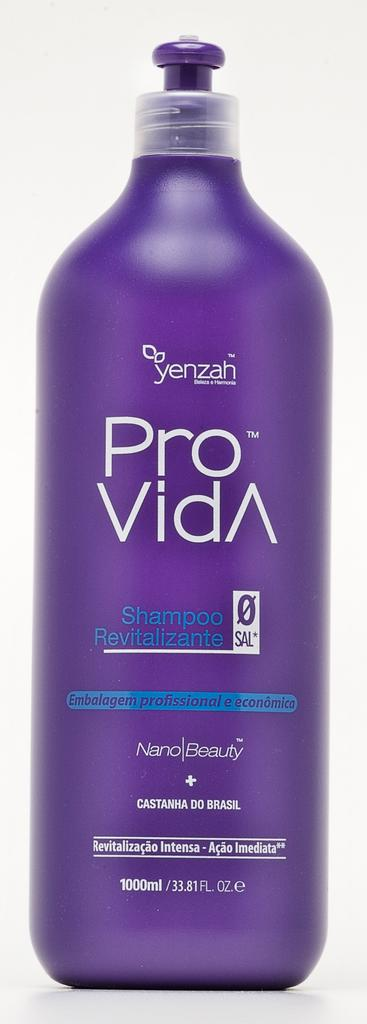<image>
Render a clear and concise summary of the photo. A photo of a purple bottle of ProVida shamppo that is 1000ml. 